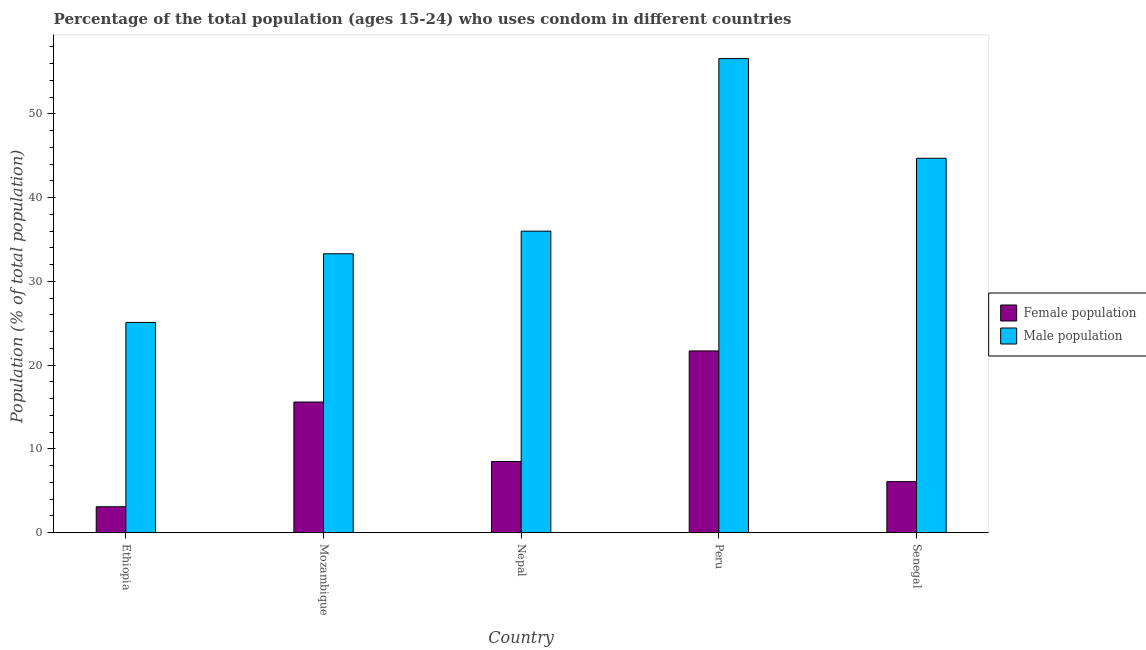How many bars are there on the 3rd tick from the left?
Offer a terse response. 2. How many bars are there on the 4th tick from the right?
Make the answer very short. 2. What is the male population in Ethiopia?
Keep it short and to the point. 25.1. Across all countries, what is the maximum male population?
Offer a very short reply. 56.6. Across all countries, what is the minimum male population?
Make the answer very short. 25.1. In which country was the male population minimum?
Your answer should be compact. Ethiopia. What is the total female population in the graph?
Your answer should be compact. 55. What is the difference between the male population in Peru and that in Senegal?
Provide a succinct answer. 11.9. What is the difference between the male population in Peru and the female population in Ethiopia?
Offer a terse response. 53.5. What is the difference between the female population and male population in Nepal?
Provide a short and direct response. -27.5. What is the ratio of the male population in Mozambique to that in Senegal?
Offer a terse response. 0.74. Is the male population in Nepal less than that in Senegal?
Your answer should be very brief. Yes. Is the difference between the female population in Nepal and Peru greater than the difference between the male population in Nepal and Peru?
Your answer should be very brief. Yes. What is the difference between the highest and the second highest male population?
Make the answer very short. 11.9. What is the difference between the highest and the lowest male population?
Offer a very short reply. 31.5. In how many countries, is the female population greater than the average female population taken over all countries?
Your response must be concise. 2. What does the 1st bar from the left in Ethiopia represents?
Ensure brevity in your answer.  Female population. What does the 1st bar from the right in Peru represents?
Provide a short and direct response. Male population. How many bars are there?
Provide a succinct answer. 10. How many countries are there in the graph?
Your answer should be very brief. 5. What is the difference between two consecutive major ticks on the Y-axis?
Your response must be concise. 10. Are the values on the major ticks of Y-axis written in scientific E-notation?
Give a very brief answer. No. How many legend labels are there?
Offer a very short reply. 2. What is the title of the graph?
Provide a succinct answer. Percentage of the total population (ages 15-24) who uses condom in different countries. What is the label or title of the Y-axis?
Make the answer very short. Population (% of total population) . What is the Population (% of total population)  in Male population in Ethiopia?
Ensure brevity in your answer.  25.1. What is the Population (% of total population)  in Female population in Mozambique?
Keep it short and to the point. 15.6. What is the Population (% of total population)  in Male population in Mozambique?
Your response must be concise. 33.3. What is the Population (% of total population)  of Male population in Nepal?
Offer a terse response. 36. What is the Population (% of total population)  of Female population in Peru?
Offer a very short reply. 21.7. What is the Population (% of total population)  of Male population in Peru?
Your answer should be very brief. 56.6. What is the Population (% of total population)  of Female population in Senegal?
Offer a very short reply. 6.1. What is the Population (% of total population)  in Male population in Senegal?
Make the answer very short. 44.7. Across all countries, what is the maximum Population (% of total population)  of Female population?
Make the answer very short. 21.7. Across all countries, what is the maximum Population (% of total population)  in Male population?
Provide a succinct answer. 56.6. Across all countries, what is the minimum Population (% of total population)  in Female population?
Offer a very short reply. 3.1. Across all countries, what is the minimum Population (% of total population)  in Male population?
Offer a terse response. 25.1. What is the total Population (% of total population)  in Female population in the graph?
Keep it short and to the point. 55. What is the total Population (% of total population)  of Male population in the graph?
Ensure brevity in your answer.  195.7. What is the difference between the Population (% of total population)  of Female population in Ethiopia and that in Mozambique?
Offer a terse response. -12.5. What is the difference between the Population (% of total population)  of Female population in Ethiopia and that in Peru?
Provide a short and direct response. -18.6. What is the difference between the Population (% of total population)  of Male population in Ethiopia and that in Peru?
Keep it short and to the point. -31.5. What is the difference between the Population (% of total population)  of Female population in Ethiopia and that in Senegal?
Ensure brevity in your answer.  -3. What is the difference between the Population (% of total population)  in Male population in Ethiopia and that in Senegal?
Make the answer very short. -19.6. What is the difference between the Population (% of total population)  in Male population in Mozambique and that in Peru?
Provide a succinct answer. -23.3. What is the difference between the Population (% of total population)  of Female population in Mozambique and that in Senegal?
Your response must be concise. 9.5. What is the difference between the Population (% of total population)  in Female population in Nepal and that in Peru?
Keep it short and to the point. -13.2. What is the difference between the Population (% of total population)  of Male population in Nepal and that in Peru?
Offer a very short reply. -20.6. What is the difference between the Population (% of total population)  of Female population in Ethiopia and the Population (% of total population)  of Male population in Mozambique?
Keep it short and to the point. -30.2. What is the difference between the Population (% of total population)  in Female population in Ethiopia and the Population (% of total population)  in Male population in Nepal?
Offer a terse response. -32.9. What is the difference between the Population (% of total population)  of Female population in Ethiopia and the Population (% of total population)  of Male population in Peru?
Make the answer very short. -53.5. What is the difference between the Population (% of total population)  in Female population in Ethiopia and the Population (% of total population)  in Male population in Senegal?
Your answer should be compact. -41.6. What is the difference between the Population (% of total population)  in Female population in Mozambique and the Population (% of total population)  in Male population in Nepal?
Give a very brief answer. -20.4. What is the difference between the Population (% of total population)  of Female population in Mozambique and the Population (% of total population)  of Male population in Peru?
Your answer should be compact. -41. What is the difference between the Population (% of total population)  of Female population in Mozambique and the Population (% of total population)  of Male population in Senegal?
Give a very brief answer. -29.1. What is the difference between the Population (% of total population)  of Female population in Nepal and the Population (% of total population)  of Male population in Peru?
Offer a terse response. -48.1. What is the difference between the Population (% of total population)  in Female population in Nepal and the Population (% of total population)  in Male population in Senegal?
Your answer should be compact. -36.2. What is the difference between the Population (% of total population)  in Female population in Peru and the Population (% of total population)  in Male population in Senegal?
Your response must be concise. -23. What is the average Population (% of total population)  of Female population per country?
Make the answer very short. 11. What is the average Population (% of total population)  of Male population per country?
Offer a terse response. 39.14. What is the difference between the Population (% of total population)  of Female population and Population (% of total population)  of Male population in Mozambique?
Give a very brief answer. -17.7. What is the difference between the Population (% of total population)  of Female population and Population (% of total population)  of Male population in Nepal?
Your answer should be very brief. -27.5. What is the difference between the Population (% of total population)  of Female population and Population (% of total population)  of Male population in Peru?
Make the answer very short. -34.9. What is the difference between the Population (% of total population)  in Female population and Population (% of total population)  in Male population in Senegal?
Give a very brief answer. -38.6. What is the ratio of the Population (% of total population)  of Female population in Ethiopia to that in Mozambique?
Your answer should be compact. 0.2. What is the ratio of the Population (% of total population)  in Male population in Ethiopia to that in Mozambique?
Your response must be concise. 0.75. What is the ratio of the Population (% of total population)  in Female population in Ethiopia to that in Nepal?
Provide a short and direct response. 0.36. What is the ratio of the Population (% of total population)  in Male population in Ethiopia to that in Nepal?
Ensure brevity in your answer.  0.7. What is the ratio of the Population (% of total population)  in Female population in Ethiopia to that in Peru?
Your answer should be very brief. 0.14. What is the ratio of the Population (% of total population)  in Male population in Ethiopia to that in Peru?
Give a very brief answer. 0.44. What is the ratio of the Population (% of total population)  of Female population in Ethiopia to that in Senegal?
Provide a short and direct response. 0.51. What is the ratio of the Population (% of total population)  of Male population in Ethiopia to that in Senegal?
Offer a very short reply. 0.56. What is the ratio of the Population (% of total population)  of Female population in Mozambique to that in Nepal?
Make the answer very short. 1.84. What is the ratio of the Population (% of total population)  of Male population in Mozambique to that in Nepal?
Make the answer very short. 0.93. What is the ratio of the Population (% of total population)  in Female population in Mozambique to that in Peru?
Offer a terse response. 0.72. What is the ratio of the Population (% of total population)  of Male population in Mozambique to that in Peru?
Offer a very short reply. 0.59. What is the ratio of the Population (% of total population)  in Female population in Mozambique to that in Senegal?
Offer a very short reply. 2.56. What is the ratio of the Population (% of total population)  in Male population in Mozambique to that in Senegal?
Your answer should be very brief. 0.74. What is the ratio of the Population (% of total population)  of Female population in Nepal to that in Peru?
Your answer should be compact. 0.39. What is the ratio of the Population (% of total population)  in Male population in Nepal to that in Peru?
Make the answer very short. 0.64. What is the ratio of the Population (% of total population)  in Female population in Nepal to that in Senegal?
Your answer should be compact. 1.39. What is the ratio of the Population (% of total population)  in Male population in Nepal to that in Senegal?
Provide a succinct answer. 0.81. What is the ratio of the Population (% of total population)  in Female population in Peru to that in Senegal?
Make the answer very short. 3.56. What is the ratio of the Population (% of total population)  in Male population in Peru to that in Senegal?
Your answer should be very brief. 1.27. What is the difference between the highest and the second highest Population (% of total population)  of Male population?
Provide a succinct answer. 11.9. What is the difference between the highest and the lowest Population (% of total population)  of Male population?
Offer a very short reply. 31.5. 